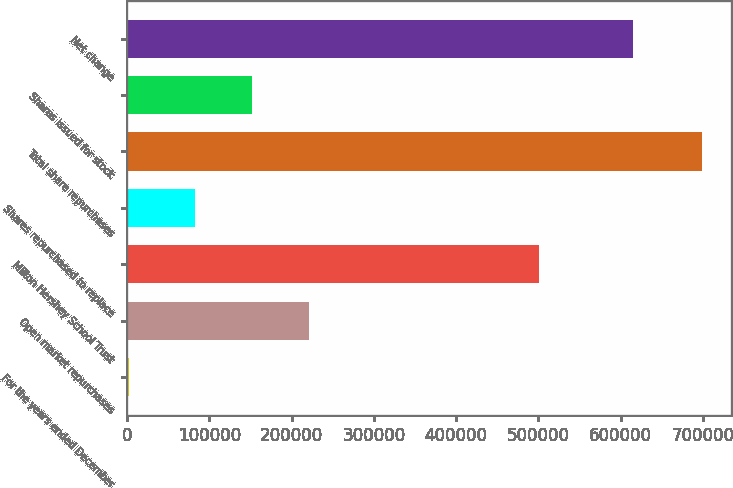Convert chart. <chart><loc_0><loc_0><loc_500><loc_500><bar_chart><fcel>For the years ended December<fcel>Open market repurchases<fcel>Milton Hershey School Trust<fcel>Shares repurchased to replace<fcel>Total share repurchases<fcel>Shares issued for stock<fcel>Net change<nl><fcel>2004<fcel>221314<fcel>501373<fcel>81933<fcel>698910<fcel>151624<fcel>614863<nl></chart> 